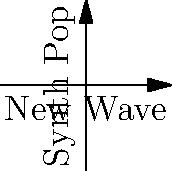In the 2D space of 80s music genres, vector A represents New Wave, and vector B represents Synth Pop. If A = (3, 2) and B = (4, 1), calculate the projection of A onto B. What does this projection signify in terms of the relationship between these two genres? To solve this problem, we'll follow these steps:

1) The formula for projecting vector A onto vector B is:

   $$ \text{proj}_B A = \frac{A \cdot B}{||B||^2} B $$

2) First, let's calculate the dot product A · B:
   $$ A \cdot B = (3)(4) + (2)(1) = 12 + 2 = 14 $$

3) Next, calculate ||B||^2 (the magnitude of B squared):
   $$ ||B||^2 = 4^2 + 1^2 = 16 + 1 = 17 $$

4) Now we can calculate the scalar projection:
   $$ \frac{A \cdot B}{||B||^2} = \frac{14}{17} $$

5) Finally, multiply this scalar by vector B:
   $$ \text{proj}_B A = \frac{14}{17} (4, 1) = (\frac{56}{17}, \frac{14}{17}) $$

This projection signifies the component of New Wave (A) that aligns with Synth Pop (B). It represents the extent to which New Wave shares characteristics or influences with Synth Pop in this 2D genre space.
Answer: $(\frac{56}{17}, \frac{14}{17})$ 